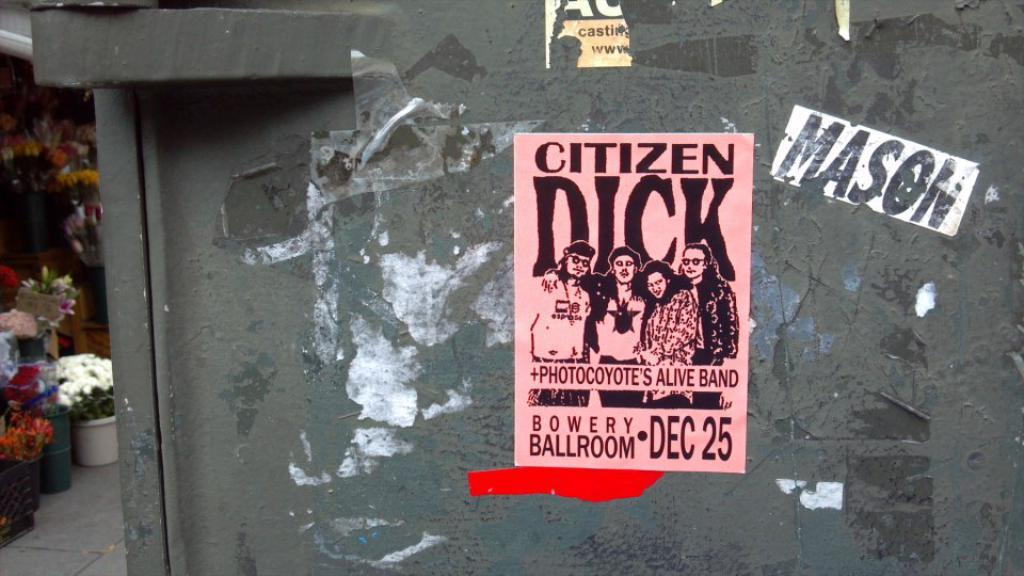<image>
Describe the image concisely. An advertisement for a band playing on December 25th 